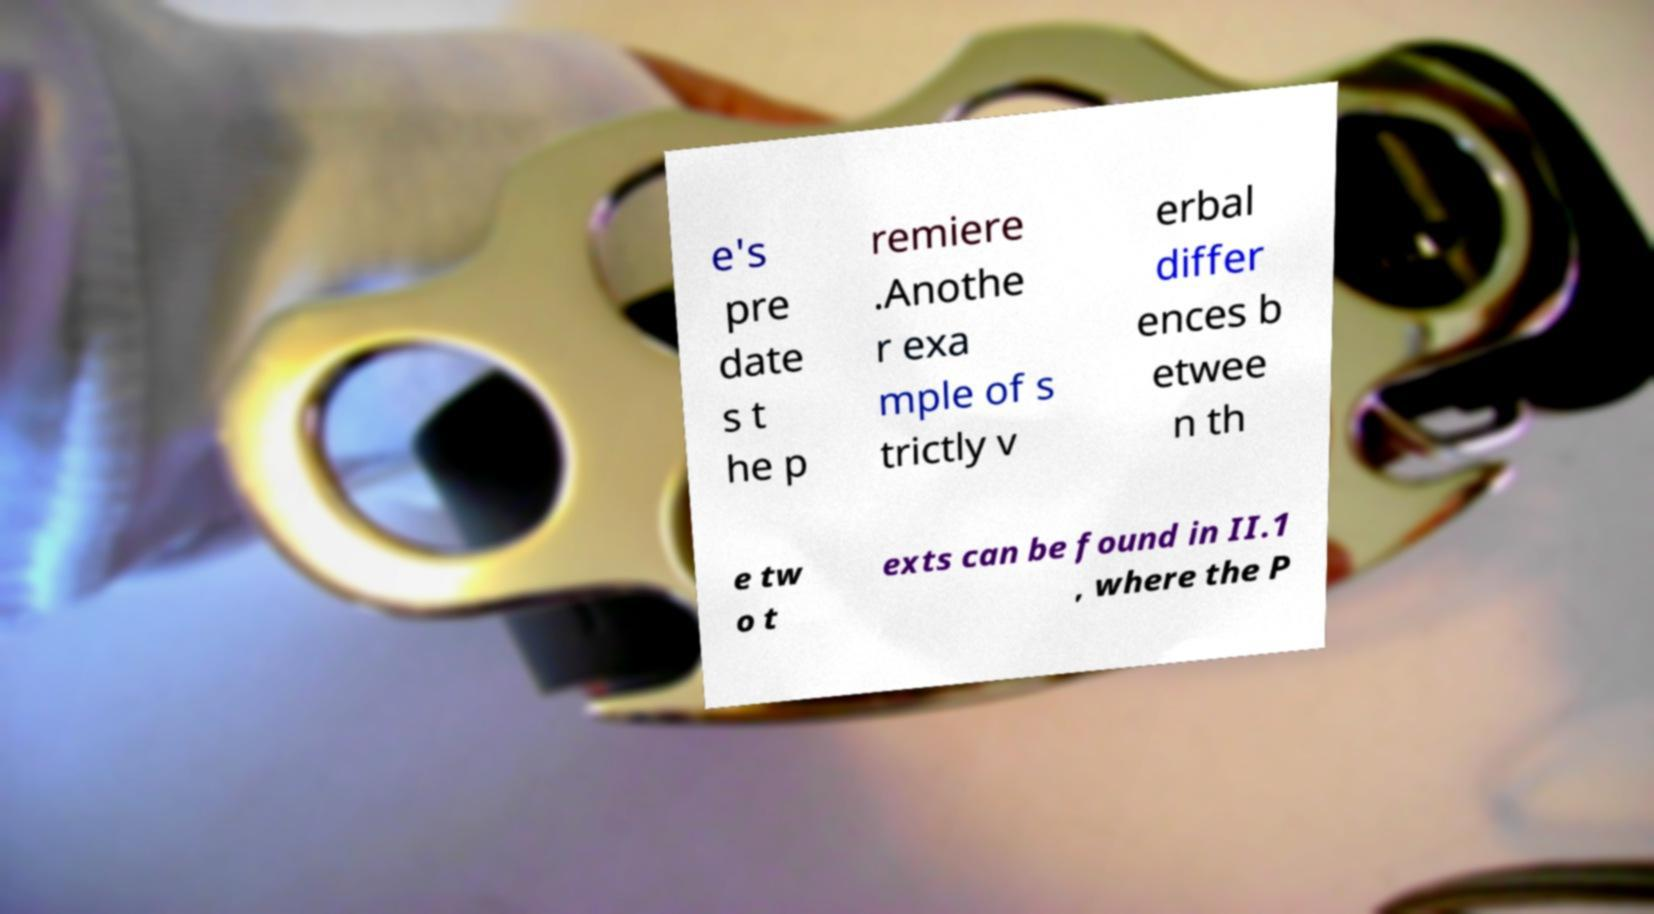Can you read and provide the text displayed in the image?This photo seems to have some interesting text. Can you extract and type it out for me? e's pre date s t he p remiere .Anothe r exa mple of s trictly v erbal differ ences b etwee n th e tw o t exts can be found in II.1 , where the P 